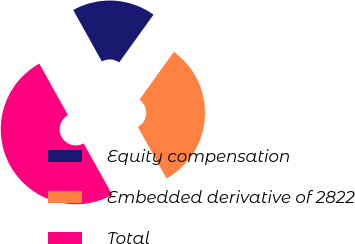<chart> <loc_0><loc_0><loc_500><loc_500><pie_chart><fcel>Equity compensation<fcel>Embedded derivative of 2822<fcel>Total<nl><fcel>18.0%<fcel>32.0%<fcel>50.0%<nl></chart> 